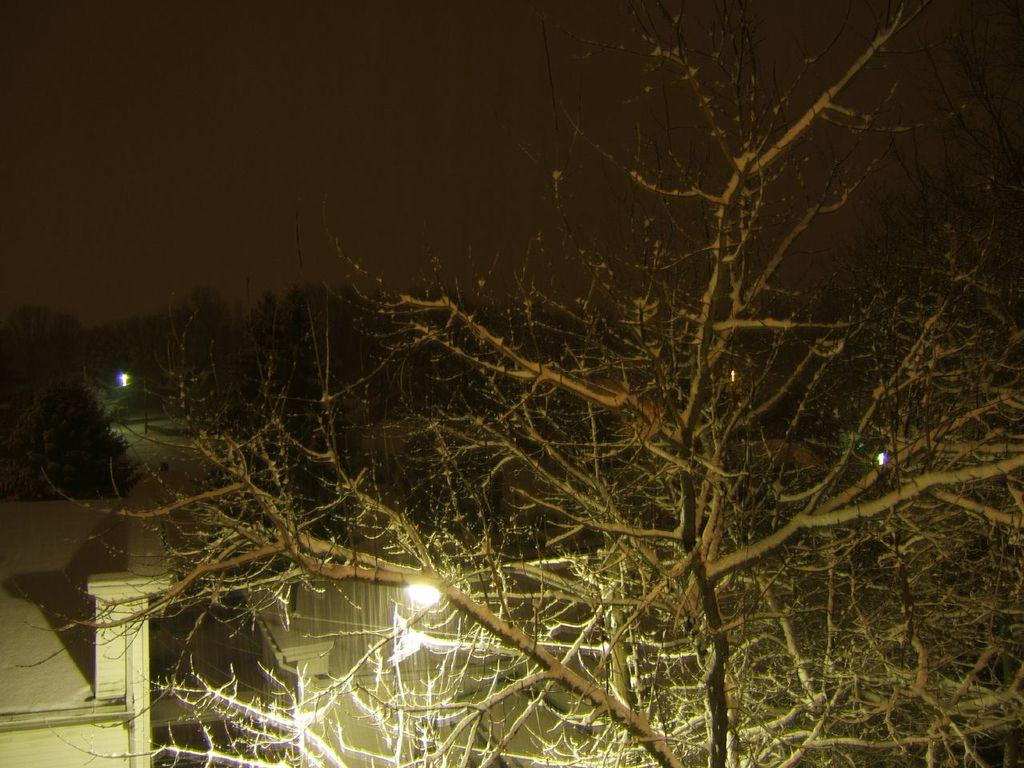What is located in the foreground of the picture? There is a tree in the foreground of the picture. What can be seen in the center of the picture? There are trees, street lights, and buildings in the center of the picture. How many types of objects are present in the center of the picture? There are three types of objects present in the center of the picture: trees, street lights, and buildings. What is the condition of the top part of the image? The top part of the image is dark. What type of trousers is the tree wearing in the image? Trees do not wear trousers, as they are not human or capable of wearing clothing. 